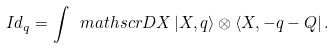Convert formula to latex. <formula><loc_0><loc_0><loc_500><loc_500>I d _ { q } = \int \ m a t h s c r { D } X \, | X , q \rangle \otimes \langle X , - q - Q | \, .</formula> 